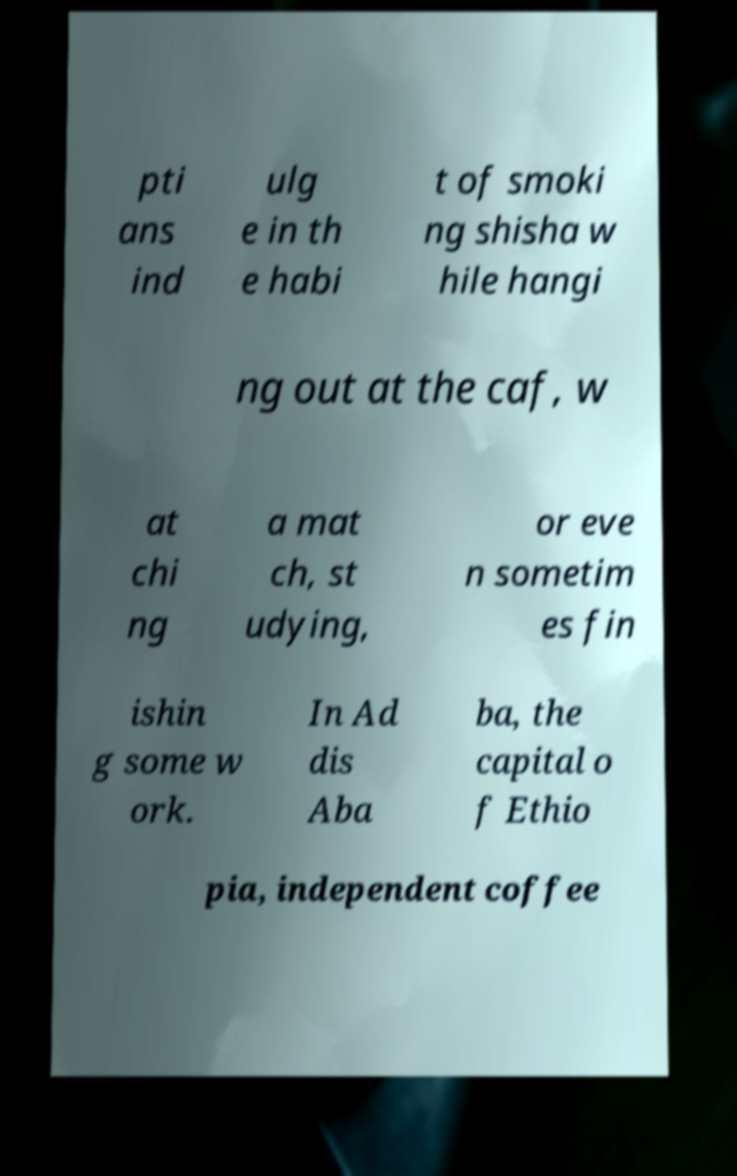Please identify and transcribe the text found in this image. pti ans ind ulg e in th e habi t of smoki ng shisha w hile hangi ng out at the caf, w at chi ng a mat ch, st udying, or eve n sometim es fin ishin g some w ork. In Ad dis Aba ba, the capital o f Ethio pia, independent coffee 